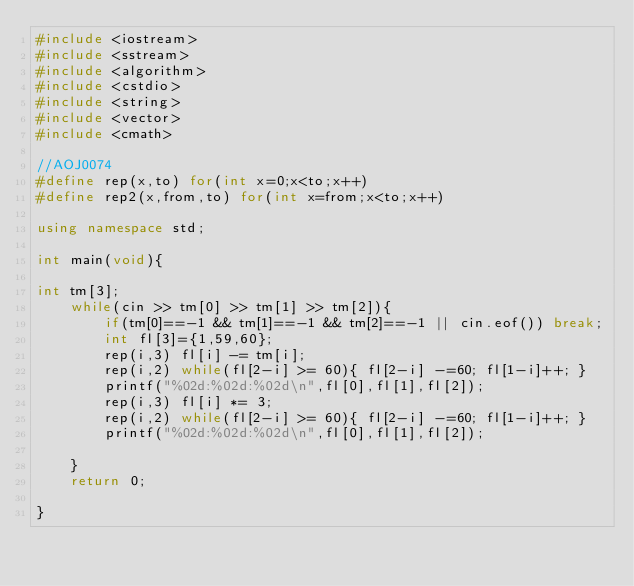<code> <loc_0><loc_0><loc_500><loc_500><_C++_>#include <iostream>
#include <sstream>
#include <algorithm>
#include <cstdio>
#include <string>
#include <vector>
#include <cmath>

//AOJ0074
#define rep(x,to) for(int x=0;x<to;x++)
#define rep2(x,from,to) for(int x=from;x<to;x++)

using namespace std;

int main(void){

int tm[3];
	while(cin >> tm[0] >> tm[1] >> tm[2]){
		if(tm[0]==-1 && tm[1]==-1 && tm[2]==-1 || cin.eof()) break;
		int fl[3]={1,59,60};
		rep(i,3) fl[i] -= tm[i];
		rep(i,2) while(fl[2-i] >= 60){ fl[2-i] -=60; fl[1-i]++; }
		printf("%02d:%02d:%02d\n",fl[0],fl[1],fl[2]);
		rep(i,3) fl[i] *= 3;
		rep(i,2) while(fl[2-i] >= 60){ fl[2-i] -=60; fl[1-i]++; }
		printf("%02d:%02d:%02d\n",fl[0],fl[1],fl[2]);
		
	}
	return 0;
	
}</code> 